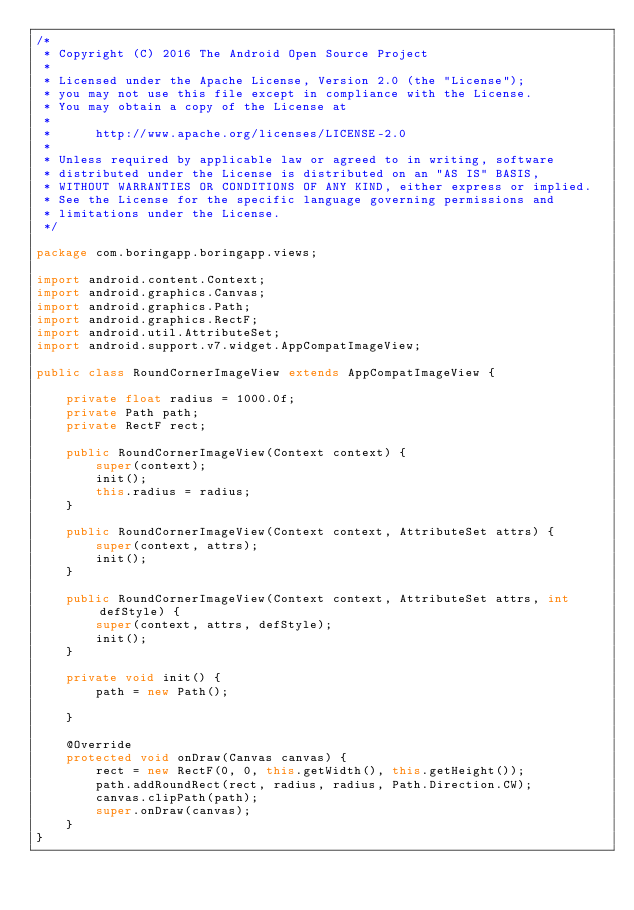Convert code to text. <code><loc_0><loc_0><loc_500><loc_500><_Java_>/*
 * Copyright (C) 2016 The Android Open Source Project
 *
 * Licensed under the Apache License, Version 2.0 (the "License");
 * you may not use this file except in compliance with the License.
 * You may obtain a copy of the License at
 *
 *      http://www.apache.org/licenses/LICENSE-2.0
 *
 * Unless required by applicable law or agreed to in writing, software
 * distributed under the License is distributed on an "AS IS" BASIS,
 * WITHOUT WARRANTIES OR CONDITIONS OF ANY KIND, either express or implied.
 * See the License for the specific language governing permissions and
 * limitations under the License.
 */

package com.boringapp.boringapp.views;

import android.content.Context;
import android.graphics.Canvas;
import android.graphics.Path;
import android.graphics.RectF;
import android.util.AttributeSet;
import android.support.v7.widget.AppCompatImageView;

public class RoundCornerImageView extends AppCompatImageView {

    private float radius = 1000.0f;
    private Path path;
    private RectF rect;

    public RoundCornerImageView(Context context) {
        super(context);
        init();
        this.radius = radius;
    }

    public RoundCornerImageView(Context context, AttributeSet attrs) {
        super(context, attrs);
        init();
    }

    public RoundCornerImageView(Context context, AttributeSet attrs, int defStyle) {
        super(context, attrs, defStyle);
        init();
    }

    private void init() {
        path = new Path();

    }

    @Override
    protected void onDraw(Canvas canvas) {
        rect = new RectF(0, 0, this.getWidth(), this.getHeight());
        path.addRoundRect(rect, radius, radius, Path.Direction.CW);
        canvas.clipPath(path);
        super.onDraw(canvas);
    }
}
</code> 